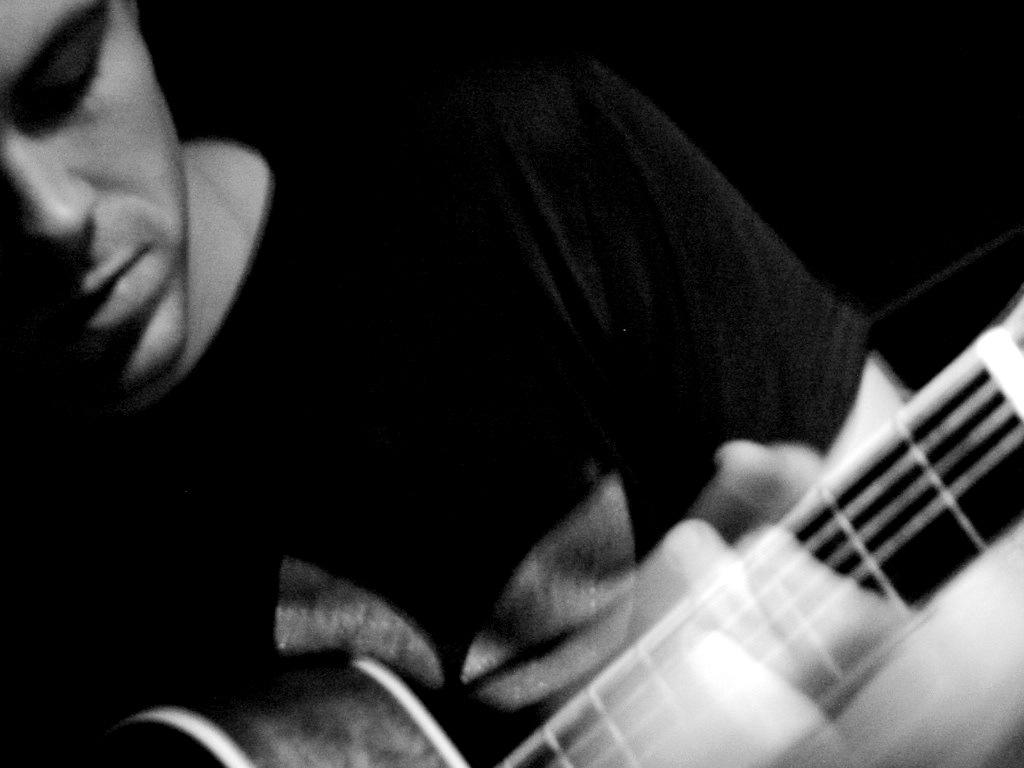What is the main subject of the image? The main subject of the image is a man. What is the man wearing in the image? The man is wearing a black T-shirt. What object is the man standing near in the image? The man is standing near a musical instrument, specifically a guitar. Can you tell me how many gloves are on the man's hands in the image? There are no gloves visible on the man's hands in the image. Where is the lunchroom located in the image? There is no lunchroom present in the image. What type of apparatus is the man using to play the guitar in the image? The image does not show the man using any apparatus to play the guitar; he is simply standing near it. 